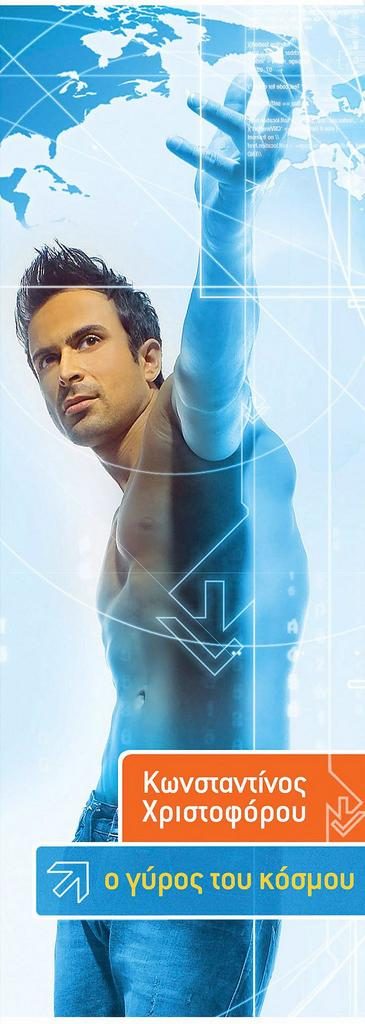What is the main subject of the image? There is a man standing in the image. What type of image is it? The image is animated. What can be found at the bottom of the image? There is text at the bottom of the image. What is present at the top of the image? There are lines at the top of the image. What object is featured in the image? There is a globe in the image. What type of cheese is being used to create the lines at the top of the image? There is no cheese present in the image, and the lines are not created using cheese. 